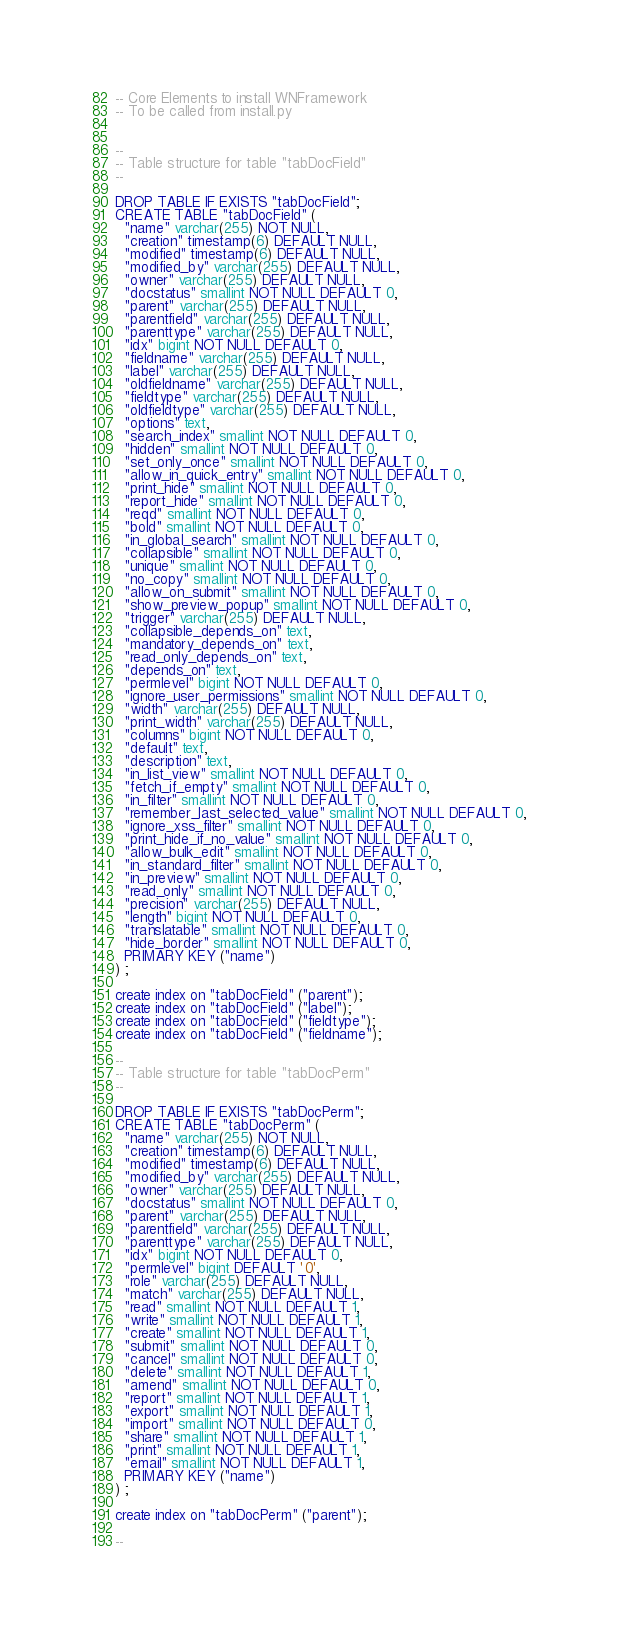Convert code to text. <code><loc_0><loc_0><loc_500><loc_500><_SQL_>-- Core Elements to install WNFramework
-- To be called from install.py


--
-- Table structure for table "tabDocField"
--

DROP TABLE IF EXISTS "tabDocField";
CREATE TABLE "tabDocField" (
  "name" varchar(255) NOT NULL,
  "creation" timestamp(6) DEFAULT NULL,
  "modified" timestamp(6) DEFAULT NULL,
  "modified_by" varchar(255) DEFAULT NULL,
  "owner" varchar(255) DEFAULT NULL,
  "docstatus" smallint NOT NULL DEFAULT 0,
  "parent" varchar(255) DEFAULT NULL,
  "parentfield" varchar(255) DEFAULT NULL,
  "parenttype" varchar(255) DEFAULT NULL,
  "idx" bigint NOT NULL DEFAULT 0,
  "fieldname" varchar(255) DEFAULT NULL,
  "label" varchar(255) DEFAULT NULL,
  "oldfieldname" varchar(255) DEFAULT NULL,
  "fieldtype" varchar(255) DEFAULT NULL,
  "oldfieldtype" varchar(255) DEFAULT NULL,
  "options" text,
  "search_index" smallint NOT NULL DEFAULT 0,
  "hidden" smallint NOT NULL DEFAULT 0,
  "set_only_once" smallint NOT NULL DEFAULT 0,
  "allow_in_quick_entry" smallint NOT NULL DEFAULT 0,
  "print_hide" smallint NOT NULL DEFAULT 0,
  "report_hide" smallint NOT NULL DEFAULT 0,
  "reqd" smallint NOT NULL DEFAULT 0,
  "bold" smallint NOT NULL DEFAULT 0,
  "in_global_search" smallint NOT NULL DEFAULT 0,
  "collapsible" smallint NOT NULL DEFAULT 0,
  "unique" smallint NOT NULL DEFAULT 0,
  "no_copy" smallint NOT NULL DEFAULT 0,
  "allow_on_submit" smallint NOT NULL DEFAULT 0,
  "show_preview_popup" smallint NOT NULL DEFAULT 0,
  "trigger" varchar(255) DEFAULT NULL,
  "collapsible_depends_on" text,
  "mandatory_depends_on" text,
  "read_only_depends_on" text,
  "depends_on" text,
  "permlevel" bigint NOT NULL DEFAULT 0,
  "ignore_user_permissions" smallint NOT NULL DEFAULT 0,
  "width" varchar(255) DEFAULT NULL,
  "print_width" varchar(255) DEFAULT NULL,
  "columns" bigint NOT NULL DEFAULT 0,
  "default" text,
  "description" text,
  "in_list_view" smallint NOT NULL DEFAULT 0,
  "fetch_if_empty" smallint NOT NULL DEFAULT 0,
  "in_filter" smallint NOT NULL DEFAULT 0,
  "remember_last_selected_value" smallint NOT NULL DEFAULT 0,
  "ignore_xss_filter" smallint NOT NULL DEFAULT 0,
  "print_hide_if_no_value" smallint NOT NULL DEFAULT 0,
  "allow_bulk_edit" smallint NOT NULL DEFAULT 0,
  "in_standard_filter" smallint NOT NULL DEFAULT 0,
  "in_preview" smallint NOT NULL DEFAULT 0,
  "read_only" smallint NOT NULL DEFAULT 0,
  "precision" varchar(255) DEFAULT NULL,
  "length" bigint NOT NULL DEFAULT 0,
  "translatable" smallint NOT NULL DEFAULT 0,
  "hide_border" smallint NOT NULL DEFAULT 0,
  PRIMARY KEY ("name")
) ;

create index on "tabDocField" ("parent");
create index on "tabDocField" ("label");
create index on "tabDocField" ("fieldtype");
create index on "tabDocField" ("fieldname");

--
-- Table structure for table "tabDocPerm"
--

DROP TABLE IF EXISTS "tabDocPerm";
CREATE TABLE "tabDocPerm" (
  "name" varchar(255) NOT NULL,
  "creation" timestamp(6) DEFAULT NULL,
  "modified" timestamp(6) DEFAULT NULL,
  "modified_by" varchar(255) DEFAULT NULL,
  "owner" varchar(255) DEFAULT NULL,
  "docstatus" smallint NOT NULL DEFAULT 0,
  "parent" varchar(255) DEFAULT NULL,
  "parentfield" varchar(255) DEFAULT NULL,
  "parenttype" varchar(255) DEFAULT NULL,
  "idx" bigint NOT NULL DEFAULT 0,
  "permlevel" bigint DEFAULT '0',
  "role" varchar(255) DEFAULT NULL,
  "match" varchar(255) DEFAULT NULL,
  "read" smallint NOT NULL DEFAULT 1,
  "write" smallint NOT NULL DEFAULT 1,
  "create" smallint NOT NULL DEFAULT 1,
  "submit" smallint NOT NULL DEFAULT 0,
  "cancel" smallint NOT NULL DEFAULT 0,
  "delete" smallint NOT NULL DEFAULT 1,
  "amend" smallint NOT NULL DEFAULT 0,
  "report" smallint NOT NULL DEFAULT 1,
  "export" smallint NOT NULL DEFAULT 1,
  "import" smallint NOT NULL DEFAULT 0,
  "share" smallint NOT NULL DEFAULT 1,
  "print" smallint NOT NULL DEFAULT 1,
  "email" smallint NOT NULL DEFAULT 1,
  PRIMARY KEY ("name")
) ;

create index on "tabDocPerm" ("parent");

--</code> 